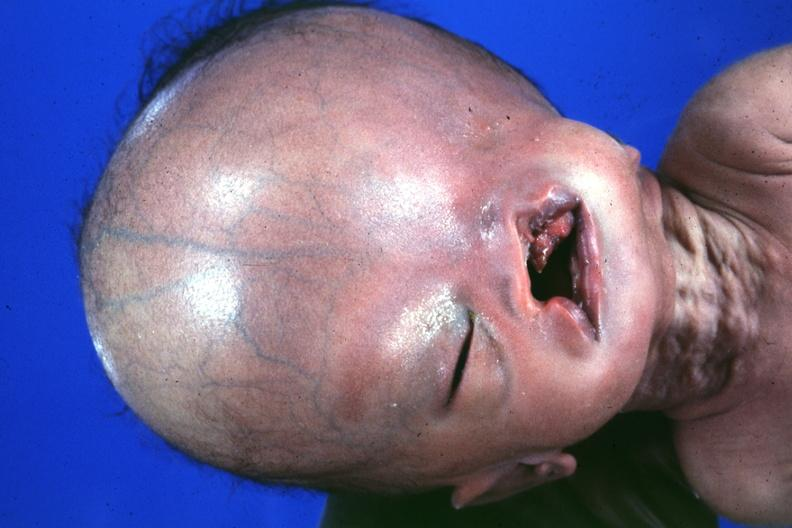what see protocol for details?
Answer the question using a single word or phrase. Absence of palpebral fissure cleft palate 